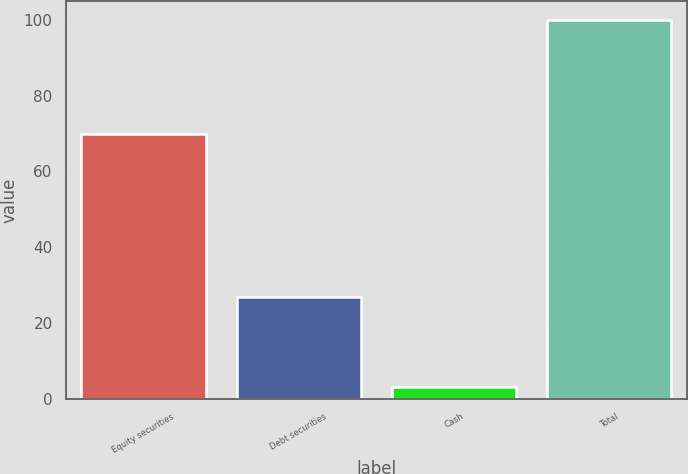Convert chart. <chart><loc_0><loc_0><loc_500><loc_500><bar_chart><fcel>Equity securities<fcel>Debt securities<fcel>Cash<fcel>Total<nl><fcel>70<fcel>27<fcel>3<fcel>100<nl></chart> 